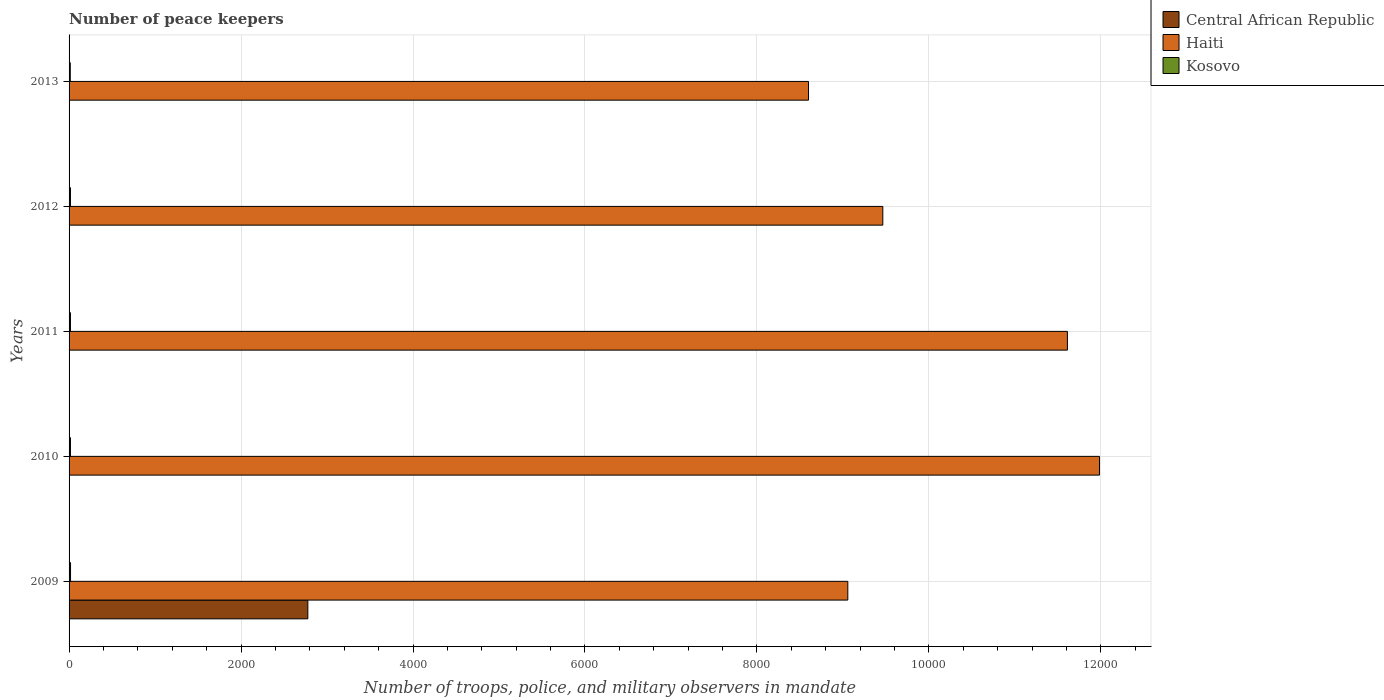Are the number of bars per tick equal to the number of legend labels?
Offer a very short reply. Yes. Are the number of bars on each tick of the Y-axis equal?
Ensure brevity in your answer.  Yes. How many bars are there on the 1st tick from the top?
Ensure brevity in your answer.  3. What is the label of the 5th group of bars from the top?
Ensure brevity in your answer.  2009. Across all years, what is the maximum number of peace keepers in in Kosovo?
Offer a terse response. 17. In which year was the number of peace keepers in in Central African Republic minimum?
Ensure brevity in your answer.  2010. What is the total number of peace keepers in in Kosovo in the graph?
Ensure brevity in your answer.  79. What is the difference between the number of peace keepers in in Haiti in 2010 and that in 2013?
Offer a very short reply. 3384. What is the average number of peace keepers in in Haiti per year?
Your answer should be compact. 1.01e+04. In the year 2012, what is the difference between the number of peace keepers in in Kosovo and number of peace keepers in in Central African Republic?
Offer a very short reply. 12. In how many years, is the number of peace keepers in in Central African Republic greater than 4000 ?
Offer a terse response. 0. What is the ratio of the number of peace keepers in in Kosovo in 2011 to that in 2012?
Your answer should be compact. 1. What is the difference between the highest and the second highest number of peace keepers in in Haiti?
Your response must be concise. 373. What is the difference between the highest and the lowest number of peace keepers in in Kosovo?
Ensure brevity in your answer.  3. In how many years, is the number of peace keepers in in Central African Republic greater than the average number of peace keepers in in Central African Republic taken over all years?
Ensure brevity in your answer.  1. Is the sum of the number of peace keepers in in Haiti in 2009 and 2012 greater than the maximum number of peace keepers in in Central African Republic across all years?
Provide a succinct answer. Yes. What does the 1st bar from the top in 2012 represents?
Provide a succinct answer. Kosovo. What does the 3rd bar from the bottom in 2009 represents?
Offer a terse response. Kosovo. How many bars are there?
Keep it short and to the point. 15. Are all the bars in the graph horizontal?
Offer a very short reply. Yes. What is the difference between two consecutive major ticks on the X-axis?
Provide a succinct answer. 2000. Does the graph contain grids?
Provide a short and direct response. Yes. Where does the legend appear in the graph?
Offer a terse response. Top right. How many legend labels are there?
Offer a terse response. 3. What is the title of the graph?
Keep it short and to the point. Number of peace keepers. What is the label or title of the X-axis?
Your response must be concise. Number of troops, police, and military observers in mandate. What is the label or title of the Y-axis?
Keep it short and to the point. Years. What is the Number of troops, police, and military observers in mandate in Central African Republic in 2009?
Make the answer very short. 2777. What is the Number of troops, police, and military observers in mandate of Haiti in 2009?
Offer a very short reply. 9057. What is the Number of troops, police, and military observers in mandate of Kosovo in 2009?
Your response must be concise. 17. What is the Number of troops, police, and military observers in mandate in Haiti in 2010?
Ensure brevity in your answer.  1.20e+04. What is the Number of troops, police, and military observers in mandate of Kosovo in 2010?
Ensure brevity in your answer.  16. What is the Number of troops, police, and military observers in mandate in Haiti in 2011?
Make the answer very short. 1.16e+04. What is the Number of troops, police, and military observers in mandate of Central African Republic in 2012?
Keep it short and to the point. 4. What is the Number of troops, police, and military observers in mandate of Haiti in 2012?
Provide a succinct answer. 9464. What is the Number of troops, police, and military observers in mandate of Kosovo in 2012?
Offer a terse response. 16. What is the Number of troops, police, and military observers in mandate of Central African Republic in 2013?
Give a very brief answer. 4. What is the Number of troops, police, and military observers in mandate of Haiti in 2013?
Give a very brief answer. 8600. What is the Number of troops, police, and military observers in mandate in Kosovo in 2013?
Provide a short and direct response. 14. Across all years, what is the maximum Number of troops, police, and military observers in mandate in Central African Republic?
Keep it short and to the point. 2777. Across all years, what is the maximum Number of troops, police, and military observers in mandate in Haiti?
Ensure brevity in your answer.  1.20e+04. Across all years, what is the maximum Number of troops, police, and military observers in mandate in Kosovo?
Keep it short and to the point. 17. Across all years, what is the minimum Number of troops, police, and military observers in mandate of Central African Republic?
Provide a short and direct response. 3. Across all years, what is the minimum Number of troops, police, and military observers in mandate of Haiti?
Offer a terse response. 8600. What is the total Number of troops, police, and military observers in mandate of Central African Republic in the graph?
Make the answer very short. 2792. What is the total Number of troops, police, and military observers in mandate of Haiti in the graph?
Provide a short and direct response. 5.07e+04. What is the total Number of troops, police, and military observers in mandate of Kosovo in the graph?
Offer a terse response. 79. What is the difference between the Number of troops, police, and military observers in mandate of Central African Republic in 2009 and that in 2010?
Provide a succinct answer. 2774. What is the difference between the Number of troops, police, and military observers in mandate of Haiti in 2009 and that in 2010?
Provide a succinct answer. -2927. What is the difference between the Number of troops, police, and military observers in mandate of Central African Republic in 2009 and that in 2011?
Your answer should be very brief. 2773. What is the difference between the Number of troops, police, and military observers in mandate of Haiti in 2009 and that in 2011?
Offer a terse response. -2554. What is the difference between the Number of troops, police, and military observers in mandate of Kosovo in 2009 and that in 2011?
Keep it short and to the point. 1. What is the difference between the Number of troops, police, and military observers in mandate in Central African Republic in 2009 and that in 2012?
Provide a short and direct response. 2773. What is the difference between the Number of troops, police, and military observers in mandate of Haiti in 2009 and that in 2012?
Provide a succinct answer. -407. What is the difference between the Number of troops, police, and military observers in mandate in Kosovo in 2009 and that in 2012?
Keep it short and to the point. 1. What is the difference between the Number of troops, police, and military observers in mandate of Central African Republic in 2009 and that in 2013?
Offer a terse response. 2773. What is the difference between the Number of troops, police, and military observers in mandate of Haiti in 2009 and that in 2013?
Provide a succinct answer. 457. What is the difference between the Number of troops, police, and military observers in mandate of Kosovo in 2009 and that in 2013?
Give a very brief answer. 3. What is the difference between the Number of troops, police, and military observers in mandate of Central African Republic in 2010 and that in 2011?
Your answer should be compact. -1. What is the difference between the Number of troops, police, and military observers in mandate of Haiti in 2010 and that in 2011?
Your response must be concise. 373. What is the difference between the Number of troops, police, and military observers in mandate of Kosovo in 2010 and that in 2011?
Your answer should be very brief. 0. What is the difference between the Number of troops, police, and military observers in mandate in Haiti in 2010 and that in 2012?
Ensure brevity in your answer.  2520. What is the difference between the Number of troops, police, and military observers in mandate in Haiti in 2010 and that in 2013?
Your answer should be very brief. 3384. What is the difference between the Number of troops, police, and military observers in mandate of Kosovo in 2010 and that in 2013?
Your response must be concise. 2. What is the difference between the Number of troops, police, and military observers in mandate in Central African Republic in 2011 and that in 2012?
Your answer should be very brief. 0. What is the difference between the Number of troops, police, and military observers in mandate in Haiti in 2011 and that in 2012?
Your answer should be compact. 2147. What is the difference between the Number of troops, police, and military observers in mandate of Kosovo in 2011 and that in 2012?
Ensure brevity in your answer.  0. What is the difference between the Number of troops, police, and military observers in mandate of Haiti in 2011 and that in 2013?
Your answer should be very brief. 3011. What is the difference between the Number of troops, police, and military observers in mandate of Kosovo in 2011 and that in 2013?
Give a very brief answer. 2. What is the difference between the Number of troops, police, and military observers in mandate of Central African Republic in 2012 and that in 2013?
Provide a short and direct response. 0. What is the difference between the Number of troops, police, and military observers in mandate of Haiti in 2012 and that in 2013?
Your answer should be very brief. 864. What is the difference between the Number of troops, police, and military observers in mandate of Kosovo in 2012 and that in 2013?
Ensure brevity in your answer.  2. What is the difference between the Number of troops, police, and military observers in mandate of Central African Republic in 2009 and the Number of troops, police, and military observers in mandate of Haiti in 2010?
Make the answer very short. -9207. What is the difference between the Number of troops, police, and military observers in mandate in Central African Republic in 2009 and the Number of troops, police, and military observers in mandate in Kosovo in 2010?
Make the answer very short. 2761. What is the difference between the Number of troops, police, and military observers in mandate in Haiti in 2009 and the Number of troops, police, and military observers in mandate in Kosovo in 2010?
Your answer should be very brief. 9041. What is the difference between the Number of troops, police, and military observers in mandate in Central African Republic in 2009 and the Number of troops, police, and military observers in mandate in Haiti in 2011?
Your response must be concise. -8834. What is the difference between the Number of troops, police, and military observers in mandate of Central African Republic in 2009 and the Number of troops, police, and military observers in mandate of Kosovo in 2011?
Your answer should be very brief. 2761. What is the difference between the Number of troops, police, and military observers in mandate of Haiti in 2009 and the Number of troops, police, and military observers in mandate of Kosovo in 2011?
Offer a very short reply. 9041. What is the difference between the Number of troops, police, and military observers in mandate in Central African Republic in 2009 and the Number of troops, police, and military observers in mandate in Haiti in 2012?
Ensure brevity in your answer.  -6687. What is the difference between the Number of troops, police, and military observers in mandate of Central African Republic in 2009 and the Number of troops, police, and military observers in mandate of Kosovo in 2012?
Your response must be concise. 2761. What is the difference between the Number of troops, police, and military observers in mandate of Haiti in 2009 and the Number of troops, police, and military observers in mandate of Kosovo in 2012?
Offer a terse response. 9041. What is the difference between the Number of troops, police, and military observers in mandate in Central African Republic in 2009 and the Number of troops, police, and military observers in mandate in Haiti in 2013?
Provide a short and direct response. -5823. What is the difference between the Number of troops, police, and military observers in mandate in Central African Republic in 2009 and the Number of troops, police, and military observers in mandate in Kosovo in 2013?
Ensure brevity in your answer.  2763. What is the difference between the Number of troops, police, and military observers in mandate of Haiti in 2009 and the Number of troops, police, and military observers in mandate of Kosovo in 2013?
Provide a short and direct response. 9043. What is the difference between the Number of troops, police, and military observers in mandate of Central African Republic in 2010 and the Number of troops, police, and military observers in mandate of Haiti in 2011?
Your response must be concise. -1.16e+04. What is the difference between the Number of troops, police, and military observers in mandate in Haiti in 2010 and the Number of troops, police, and military observers in mandate in Kosovo in 2011?
Your response must be concise. 1.20e+04. What is the difference between the Number of troops, police, and military observers in mandate in Central African Republic in 2010 and the Number of troops, police, and military observers in mandate in Haiti in 2012?
Your response must be concise. -9461. What is the difference between the Number of troops, police, and military observers in mandate of Central African Republic in 2010 and the Number of troops, police, and military observers in mandate of Kosovo in 2012?
Make the answer very short. -13. What is the difference between the Number of troops, police, and military observers in mandate in Haiti in 2010 and the Number of troops, police, and military observers in mandate in Kosovo in 2012?
Make the answer very short. 1.20e+04. What is the difference between the Number of troops, police, and military observers in mandate of Central African Republic in 2010 and the Number of troops, police, and military observers in mandate of Haiti in 2013?
Keep it short and to the point. -8597. What is the difference between the Number of troops, police, and military observers in mandate of Central African Republic in 2010 and the Number of troops, police, and military observers in mandate of Kosovo in 2013?
Offer a very short reply. -11. What is the difference between the Number of troops, police, and military observers in mandate in Haiti in 2010 and the Number of troops, police, and military observers in mandate in Kosovo in 2013?
Give a very brief answer. 1.20e+04. What is the difference between the Number of troops, police, and military observers in mandate of Central African Republic in 2011 and the Number of troops, police, and military observers in mandate of Haiti in 2012?
Offer a very short reply. -9460. What is the difference between the Number of troops, police, and military observers in mandate of Central African Republic in 2011 and the Number of troops, police, and military observers in mandate of Kosovo in 2012?
Your answer should be very brief. -12. What is the difference between the Number of troops, police, and military observers in mandate of Haiti in 2011 and the Number of troops, police, and military observers in mandate of Kosovo in 2012?
Make the answer very short. 1.16e+04. What is the difference between the Number of troops, police, and military observers in mandate of Central African Republic in 2011 and the Number of troops, police, and military observers in mandate of Haiti in 2013?
Ensure brevity in your answer.  -8596. What is the difference between the Number of troops, police, and military observers in mandate of Haiti in 2011 and the Number of troops, police, and military observers in mandate of Kosovo in 2013?
Offer a very short reply. 1.16e+04. What is the difference between the Number of troops, police, and military observers in mandate of Central African Republic in 2012 and the Number of troops, police, and military observers in mandate of Haiti in 2013?
Offer a terse response. -8596. What is the difference between the Number of troops, police, and military observers in mandate of Haiti in 2012 and the Number of troops, police, and military observers in mandate of Kosovo in 2013?
Your answer should be compact. 9450. What is the average Number of troops, police, and military observers in mandate in Central African Republic per year?
Your response must be concise. 558.4. What is the average Number of troops, police, and military observers in mandate in Haiti per year?
Your answer should be very brief. 1.01e+04. What is the average Number of troops, police, and military observers in mandate in Kosovo per year?
Keep it short and to the point. 15.8. In the year 2009, what is the difference between the Number of troops, police, and military observers in mandate in Central African Republic and Number of troops, police, and military observers in mandate in Haiti?
Your answer should be compact. -6280. In the year 2009, what is the difference between the Number of troops, police, and military observers in mandate of Central African Republic and Number of troops, police, and military observers in mandate of Kosovo?
Offer a terse response. 2760. In the year 2009, what is the difference between the Number of troops, police, and military observers in mandate in Haiti and Number of troops, police, and military observers in mandate in Kosovo?
Make the answer very short. 9040. In the year 2010, what is the difference between the Number of troops, police, and military observers in mandate in Central African Republic and Number of troops, police, and military observers in mandate in Haiti?
Your answer should be very brief. -1.20e+04. In the year 2010, what is the difference between the Number of troops, police, and military observers in mandate of Central African Republic and Number of troops, police, and military observers in mandate of Kosovo?
Your answer should be very brief. -13. In the year 2010, what is the difference between the Number of troops, police, and military observers in mandate of Haiti and Number of troops, police, and military observers in mandate of Kosovo?
Give a very brief answer. 1.20e+04. In the year 2011, what is the difference between the Number of troops, police, and military observers in mandate in Central African Republic and Number of troops, police, and military observers in mandate in Haiti?
Keep it short and to the point. -1.16e+04. In the year 2011, what is the difference between the Number of troops, police, and military observers in mandate in Haiti and Number of troops, police, and military observers in mandate in Kosovo?
Provide a short and direct response. 1.16e+04. In the year 2012, what is the difference between the Number of troops, police, and military observers in mandate of Central African Republic and Number of troops, police, and military observers in mandate of Haiti?
Your answer should be very brief. -9460. In the year 2012, what is the difference between the Number of troops, police, and military observers in mandate in Haiti and Number of troops, police, and military observers in mandate in Kosovo?
Keep it short and to the point. 9448. In the year 2013, what is the difference between the Number of troops, police, and military observers in mandate of Central African Republic and Number of troops, police, and military observers in mandate of Haiti?
Provide a short and direct response. -8596. In the year 2013, what is the difference between the Number of troops, police, and military observers in mandate of Haiti and Number of troops, police, and military observers in mandate of Kosovo?
Your answer should be compact. 8586. What is the ratio of the Number of troops, police, and military observers in mandate in Central African Republic in 2009 to that in 2010?
Ensure brevity in your answer.  925.67. What is the ratio of the Number of troops, police, and military observers in mandate of Haiti in 2009 to that in 2010?
Provide a succinct answer. 0.76. What is the ratio of the Number of troops, police, and military observers in mandate of Kosovo in 2009 to that in 2010?
Provide a succinct answer. 1.06. What is the ratio of the Number of troops, police, and military observers in mandate in Central African Republic in 2009 to that in 2011?
Ensure brevity in your answer.  694.25. What is the ratio of the Number of troops, police, and military observers in mandate of Haiti in 2009 to that in 2011?
Your answer should be very brief. 0.78. What is the ratio of the Number of troops, police, and military observers in mandate in Central African Republic in 2009 to that in 2012?
Your answer should be compact. 694.25. What is the ratio of the Number of troops, police, and military observers in mandate in Haiti in 2009 to that in 2012?
Provide a succinct answer. 0.96. What is the ratio of the Number of troops, police, and military observers in mandate of Kosovo in 2009 to that in 2012?
Your answer should be compact. 1.06. What is the ratio of the Number of troops, police, and military observers in mandate in Central African Republic in 2009 to that in 2013?
Offer a terse response. 694.25. What is the ratio of the Number of troops, police, and military observers in mandate of Haiti in 2009 to that in 2013?
Offer a very short reply. 1.05. What is the ratio of the Number of troops, police, and military observers in mandate in Kosovo in 2009 to that in 2013?
Your response must be concise. 1.21. What is the ratio of the Number of troops, police, and military observers in mandate of Central African Republic in 2010 to that in 2011?
Ensure brevity in your answer.  0.75. What is the ratio of the Number of troops, police, and military observers in mandate in Haiti in 2010 to that in 2011?
Offer a terse response. 1.03. What is the ratio of the Number of troops, police, and military observers in mandate of Central African Republic in 2010 to that in 2012?
Your answer should be compact. 0.75. What is the ratio of the Number of troops, police, and military observers in mandate of Haiti in 2010 to that in 2012?
Your response must be concise. 1.27. What is the ratio of the Number of troops, police, and military observers in mandate in Central African Republic in 2010 to that in 2013?
Your answer should be compact. 0.75. What is the ratio of the Number of troops, police, and military observers in mandate in Haiti in 2010 to that in 2013?
Offer a terse response. 1.39. What is the ratio of the Number of troops, police, and military observers in mandate in Haiti in 2011 to that in 2012?
Give a very brief answer. 1.23. What is the ratio of the Number of troops, police, and military observers in mandate in Kosovo in 2011 to that in 2012?
Ensure brevity in your answer.  1. What is the ratio of the Number of troops, police, and military observers in mandate of Central African Republic in 2011 to that in 2013?
Offer a very short reply. 1. What is the ratio of the Number of troops, police, and military observers in mandate of Haiti in 2011 to that in 2013?
Provide a succinct answer. 1.35. What is the ratio of the Number of troops, police, and military observers in mandate of Central African Republic in 2012 to that in 2013?
Ensure brevity in your answer.  1. What is the ratio of the Number of troops, police, and military observers in mandate of Haiti in 2012 to that in 2013?
Provide a succinct answer. 1.1. What is the difference between the highest and the second highest Number of troops, police, and military observers in mandate of Central African Republic?
Offer a terse response. 2773. What is the difference between the highest and the second highest Number of troops, police, and military observers in mandate in Haiti?
Give a very brief answer. 373. What is the difference between the highest and the second highest Number of troops, police, and military observers in mandate of Kosovo?
Make the answer very short. 1. What is the difference between the highest and the lowest Number of troops, police, and military observers in mandate of Central African Republic?
Provide a short and direct response. 2774. What is the difference between the highest and the lowest Number of troops, police, and military observers in mandate of Haiti?
Provide a short and direct response. 3384. 